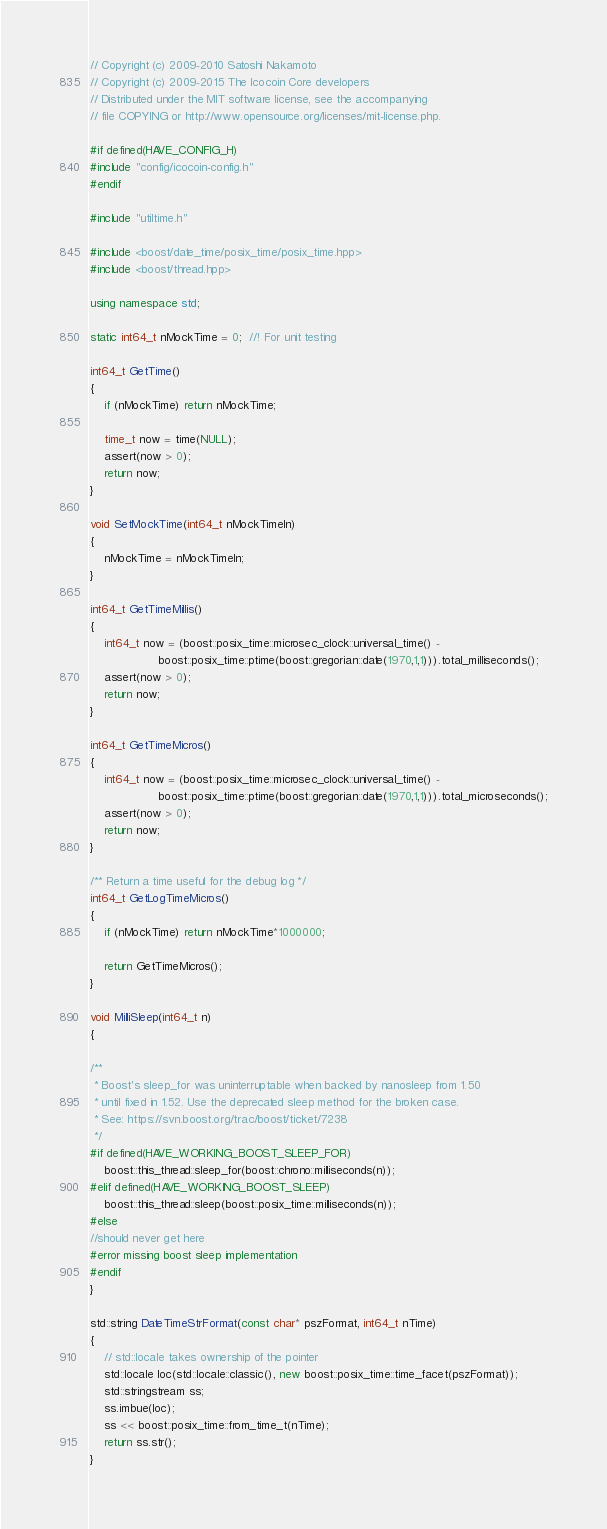<code> <loc_0><loc_0><loc_500><loc_500><_C++_>// Copyright (c) 2009-2010 Satoshi Nakamoto
// Copyright (c) 2009-2015 The Icocoin Core developers
// Distributed under the MIT software license, see the accompanying
// file COPYING or http://www.opensource.org/licenses/mit-license.php.

#if defined(HAVE_CONFIG_H)
#include "config/icocoin-config.h"
#endif

#include "utiltime.h"

#include <boost/date_time/posix_time/posix_time.hpp>
#include <boost/thread.hpp>

using namespace std;

static int64_t nMockTime = 0;  //! For unit testing

int64_t GetTime()
{
    if (nMockTime) return nMockTime;

    time_t now = time(NULL);
    assert(now > 0);
    return now;
}

void SetMockTime(int64_t nMockTimeIn)
{
    nMockTime = nMockTimeIn;
}

int64_t GetTimeMillis()
{
    int64_t now = (boost::posix_time::microsec_clock::universal_time() -
                   boost::posix_time::ptime(boost::gregorian::date(1970,1,1))).total_milliseconds();
    assert(now > 0);
    return now;
}

int64_t GetTimeMicros()
{
    int64_t now = (boost::posix_time::microsec_clock::universal_time() -
                   boost::posix_time::ptime(boost::gregorian::date(1970,1,1))).total_microseconds();
    assert(now > 0);
    return now;
}

/** Return a time useful for the debug log */
int64_t GetLogTimeMicros()
{
    if (nMockTime) return nMockTime*1000000;

    return GetTimeMicros();
}

void MilliSleep(int64_t n)
{

/**
 * Boost's sleep_for was uninterruptable when backed by nanosleep from 1.50
 * until fixed in 1.52. Use the deprecated sleep method for the broken case.
 * See: https://svn.boost.org/trac/boost/ticket/7238
 */
#if defined(HAVE_WORKING_BOOST_SLEEP_FOR)
    boost::this_thread::sleep_for(boost::chrono::milliseconds(n));
#elif defined(HAVE_WORKING_BOOST_SLEEP)
    boost::this_thread::sleep(boost::posix_time::milliseconds(n));
#else
//should never get here
#error missing boost sleep implementation
#endif
}

std::string DateTimeStrFormat(const char* pszFormat, int64_t nTime)
{
    // std::locale takes ownership of the pointer
    std::locale loc(std::locale::classic(), new boost::posix_time::time_facet(pszFormat));
    std::stringstream ss;
    ss.imbue(loc);
    ss << boost::posix_time::from_time_t(nTime);
    return ss.str();
}
</code> 